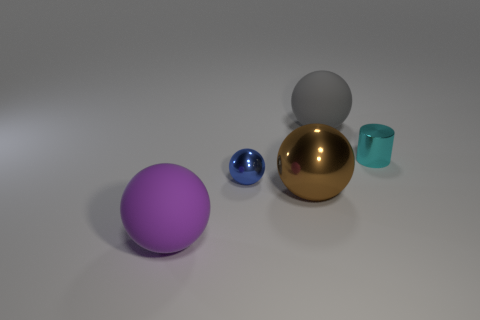How many other things are there of the same color as the tiny cylinder?
Your response must be concise. 0. How many objects are either cyan cylinders or tiny blue shiny blocks?
Offer a very short reply. 1. What is the color of the tiny metallic sphere that is behind the brown sphere?
Offer a very short reply. Blue. Is the number of blue balls to the right of the brown metallic object less than the number of gray objects?
Provide a succinct answer. Yes. Does the cylinder have the same material as the big purple object?
Provide a short and direct response. No. What number of things are rubber objects behind the cyan cylinder or matte objects that are to the right of the big purple matte sphere?
Provide a short and direct response. 1. Are there any gray matte balls that have the same size as the brown thing?
Make the answer very short. Yes. There is another big matte thing that is the same shape as the gray matte object; what color is it?
Offer a terse response. Purple. There is a matte object that is behind the purple thing; are there any small things on the left side of it?
Your response must be concise. Yes. Does the tiny metal thing in front of the metallic cylinder have the same shape as the large gray rubber thing?
Ensure brevity in your answer.  Yes. 